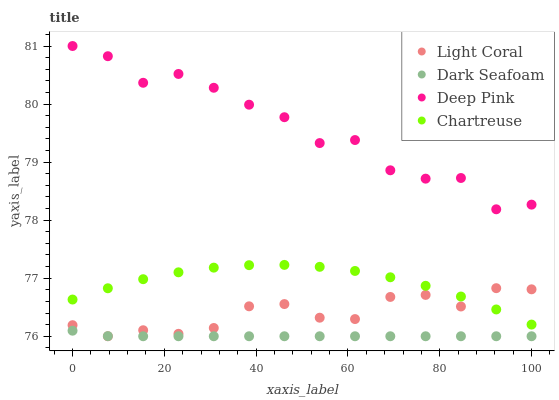Does Dark Seafoam have the minimum area under the curve?
Answer yes or no. Yes. Does Deep Pink have the maximum area under the curve?
Answer yes or no. Yes. Does Deep Pink have the minimum area under the curve?
Answer yes or no. No. Does Dark Seafoam have the maximum area under the curve?
Answer yes or no. No. Is Dark Seafoam the smoothest?
Answer yes or no. Yes. Is Deep Pink the roughest?
Answer yes or no. Yes. Is Deep Pink the smoothest?
Answer yes or no. No. Is Dark Seafoam the roughest?
Answer yes or no. No. Does Light Coral have the lowest value?
Answer yes or no. Yes. Does Deep Pink have the lowest value?
Answer yes or no. No. Does Deep Pink have the highest value?
Answer yes or no. Yes. Does Dark Seafoam have the highest value?
Answer yes or no. No. Is Dark Seafoam less than Chartreuse?
Answer yes or no. Yes. Is Chartreuse greater than Dark Seafoam?
Answer yes or no. Yes. Does Dark Seafoam intersect Light Coral?
Answer yes or no. Yes. Is Dark Seafoam less than Light Coral?
Answer yes or no. No. Is Dark Seafoam greater than Light Coral?
Answer yes or no. No. Does Dark Seafoam intersect Chartreuse?
Answer yes or no. No. 